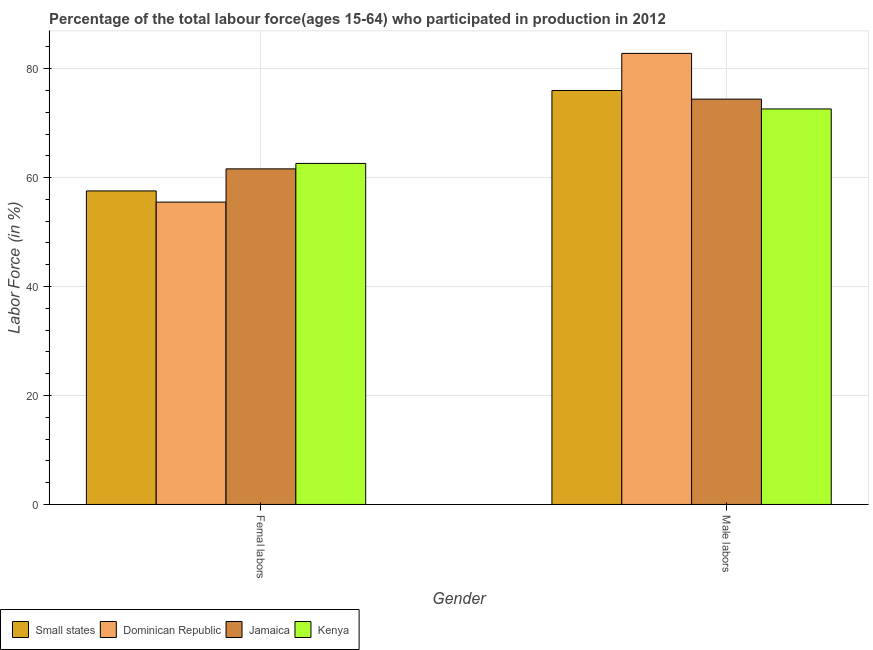How many different coloured bars are there?
Your answer should be compact. 4. How many groups of bars are there?
Make the answer very short. 2. What is the label of the 2nd group of bars from the left?
Give a very brief answer. Male labors. What is the percentage of female labor force in Small states?
Offer a very short reply. 57.55. Across all countries, what is the maximum percentage of female labor force?
Your response must be concise. 62.6. Across all countries, what is the minimum percentage of female labor force?
Keep it short and to the point. 55.5. In which country was the percentage of female labor force maximum?
Keep it short and to the point. Kenya. In which country was the percentage of female labor force minimum?
Offer a terse response. Dominican Republic. What is the total percentage of female labor force in the graph?
Your answer should be very brief. 237.25. What is the difference between the percentage of male labour force in Kenya and that in Small states?
Your response must be concise. -3.39. What is the difference between the percentage of female labor force in Jamaica and the percentage of male labour force in Dominican Republic?
Your answer should be compact. -21.2. What is the average percentage of female labor force per country?
Provide a short and direct response. 59.31. What is the difference between the percentage of female labor force and percentage of male labour force in Small states?
Your answer should be compact. -18.44. What is the ratio of the percentage of female labor force in Kenya to that in Dominican Republic?
Your answer should be compact. 1.13. Is the percentage of female labor force in Small states less than that in Dominican Republic?
Your answer should be compact. No. What does the 3rd bar from the left in Femal labors represents?
Provide a short and direct response. Jamaica. What does the 3rd bar from the right in Femal labors represents?
Offer a terse response. Dominican Republic. How many bars are there?
Make the answer very short. 8. What is the title of the graph?
Ensure brevity in your answer.  Percentage of the total labour force(ages 15-64) who participated in production in 2012. Does "Latin America(developing only)" appear as one of the legend labels in the graph?
Your response must be concise. No. What is the label or title of the X-axis?
Provide a succinct answer. Gender. What is the label or title of the Y-axis?
Your response must be concise. Labor Force (in %). What is the Labor Force (in %) of Small states in Femal labors?
Give a very brief answer. 57.55. What is the Labor Force (in %) in Dominican Republic in Femal labors?
Your answer should be very brief. 55.5. What is the Labor Force (in %) of Jamaica in Femal labors?
Keep it short and to the point. 61.6. What is the Labor Force (in %) in Kenya in Femal labors?
Make the answer very short. 62.6. What is the Labor Force (in %) in Small states in Male labors?
Your answer should be very brief. 75.99. What is the Labor Force (in %) in Dominican Republic in Male labors?
Make the answer very short. 82.8. What is the Labor Force (in %) of Jamaica in Male labors?
Provide a succinct answer. 74.4. What is the Labor Force (in %) of Kenya in Male labors?
Ensure brevity in your answer.  72.6. Across all Gender, what is the maximum Labor Force (in %) in Small states?
Give a very brief answer. 75.99. Across all Gender, what is the maximum Labor Force (in %) of Dominican Republic?
Provide a succinct answer. 82.8. Across all Gender, what is the maximum Labor Force (in %) of Jamaica?
Your answer should be very brief. 74.4. Across all Gender, what is the maximum Labor Force (in %) of Kenya?
Your answer should be compact. 72.6. Across all Gender, what is the minimum Labor Force (in %) of Small states?
Offer a terse response. 57.55. Across all Gender, what is the minimum Labor Force (in %) of Dominican Republic?
Your answer should be very brief. 55.5. Across all Gender, what is the minimum Labor Force (in %) in Jamaica?
Offer a terse response. 61.6. Across all Gender, what is the minimum Labor Force (in %) of Kenya?
Keep it short and to the point. 62.6. What is the total Labor Force (in %) in Small states in the graph?
Keep it short and to the point. 133.54. What is the total Labor Force (in %) of Dominican Republic in the graph?
Offer a very short reply. 138.3. What is the total Labor Force (in %) in Jamaica in the graph?
Keep it short and to the point. 136. What is the total Labor Force (in %) in Kenya in the graph?
Give a very brief answer. 135.2. What is the difference between the Labor Force (in %) in Small states in Femal labors and that in Male labors?
Offer a terse response. -18.44. What is the difference between the Labor Force (in %) in Dominican Republic in Femal labors and that in Male labors?
Give a very brief answer. -27.3. What is the difference between the Labor Force (in %) of Small states in Femal labors and the Labor Force (in %) of Dominican Republic in Male labors?
Offer a terse response. -25.25. What is the difference between the Labor Force (in %) in Small states in Femal labors and the Labor Force (in %) in Jamaica in Male labors?
Your answer should be compact. -16.85. What is the difference between the Labor Force (in %) of Small states in Femal labors and the Labor Force (in %) of Kenya in Male labors?
Offer a terse response. -15.05. What is the difference between the Labor Force (in %) of Dominican Republic in Femal labors and the Labor Force (in %) of Jamaica in Male labors?
Offer a very short reply. -18.9. What is the difference between the Labor Force (in %) in Dominican Republic in Femal labors and the Labor Force (in %) in Kenya in Male labors?
Your response must be concise. -17.1. What is the average Labor Force (in %) of Small states per Gender?
Offer a very short reply. 66.77. What is the average Labor Force (in %) in Dominican Republic per Gender?
Your answer should be very brief. 69.15. What is the average Labor Force (in %) of Jamaica per Gender?
Make the answer very short. 68. What is the average Labor Force (in %) in Kenya per Gender?
Give a very brief answer. 67.6. What is the difference between the Labor Force (in %) of Small states and Labor Force (in %) of Dominican Republic in Femal labors?
Your answer should be very brief. 2.05. What is the difference between the Labor Force (in %) in Small states and Labor Force (in %) in Jamaica in Femal labors?
Keep it short and to the point. -4.05. What is the difference between the Labor Force (in %) of Small states and Labor Force (in %) of Kenya in Femal labors?
Make the answer very short. -5.05. What is the difference between the Labor Force (in %) of Small states and Labor Force (in %) of Dominican Republic in Male labors?
Your answer should be very brief. -6.81. What is the difference between the Labor Force (in %) of Small states and Labor Force (in %) of Jamaica in Male labors?
Your answer should be very brief. 1.59. What is the difference between the Labor Force (in %) in Small states and Labor Force (in %) in Kenya in Male labors?
Offer a terse response. 3.39. What is the difference between the Labor Force (in %) of Dominican Republic and Labor Force (in %) of Jamaica in Male labors?
Offer a very short reply. 8.4. What is the ratio of the Labor Force (in %) in Small states in Femal labors to that in Male labors?
Ensure brevity in your answer.  0.76. What is the ratio of the Labor Force (in %) in Dominican Republic in Femal labors to that in Male labors?
Offer a very short reply. 0.67. What is the ratio of the Labor Force (in %) in Jamaica in Femal labors to that in Male labors?
Ensure brevity in your answer.  0.83. What is the ratio of the Labor Force (in %) in Kenya in Femal labors to that in Male labors?
Your answer should be very brief. 0.86. What is the difference between the highest and the second highest Labor Force (in %) in Small states?
Ensure brevity in your answer.  18.44. What is the difference between the highest and the second highest Labor Force (in %) in Dominican Republic?
Ensure brevity in your answer.  27.3. What is the difference between the highest and the second highest Labor Force (in %) in Kenya?
Your response must be concise. 10. What is the difference between the highest and the lowest Labor Force (in %) of Small states?
Ensure brevity in your answer.  18.44. What is the difference between the highest and the lowest Labor Force (in %) of Dominican Republic?
Your answer should be very brief. 27.3. 